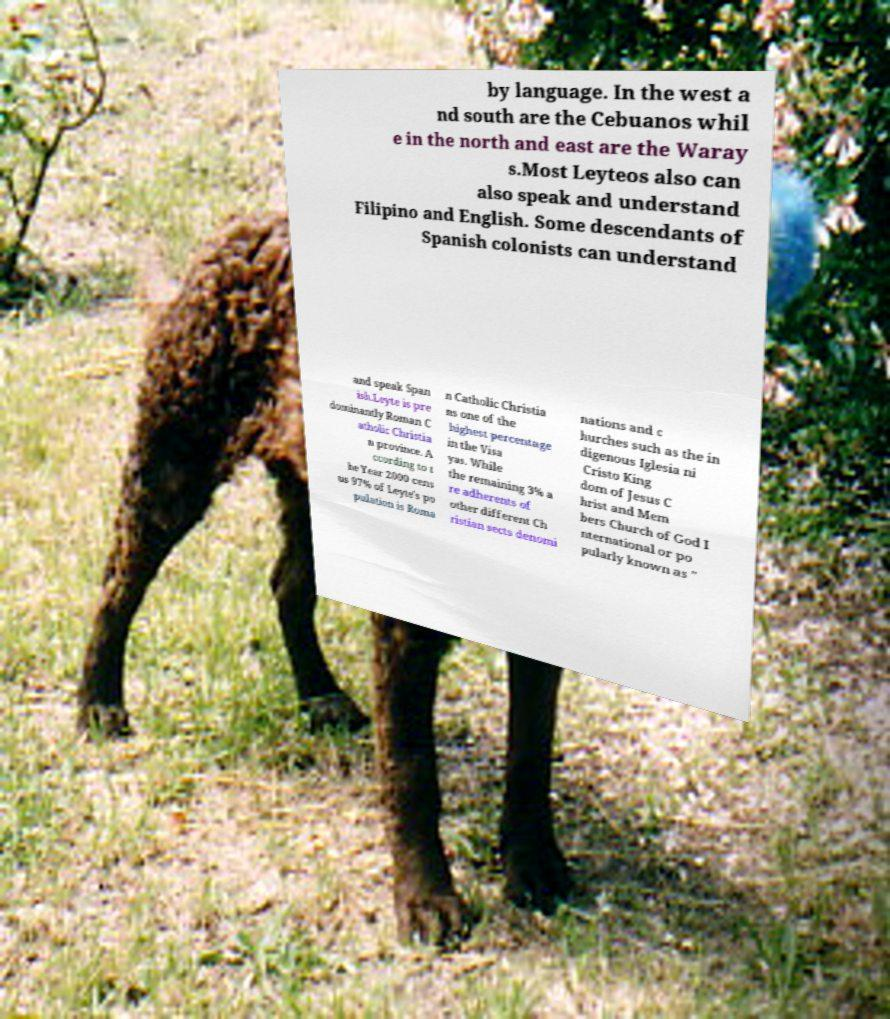Could you extract and type out the text from this image? by language. In the west a nd south are the Cebuanos whil e in the north and east are the Waray s.Most Leyteos also can also speak and understand Filipino and English. Some descendants of Spanish colonists can understand and speak Span ish.Leyte is pre dominantly Roman C atholic Christia n province. A ccording to t he Year 2000 cens us 97% of Leyte's po pulation is Roma n Catholic Christia ns one of the highest percentage in the Visa yas. While the remaining 3% a re adherents of other different Ch ristian sects denomi nations and c hurches such as the in digenous Iglesia ni Cristo King dom of Jesus C hrist and Mem bers Church of God I nternational or po pularly known as " 